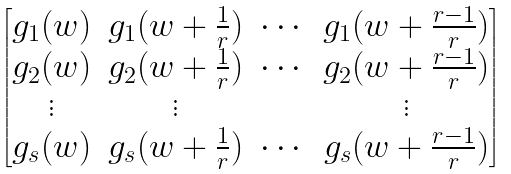Convert formula to latex. <formula><loc_0><loc_0><loc_500><loc_500>\begin{bmatrix} g _ { 1 } ( w ) & g _ { 1 } ( w + \frac { 1 } { r } ) & \cdots & g _ { 1 } ( w + \frac { r - 1 } { r } ) \\ g _ { 2 } ( w ) & g _ { 2 } ( w + \frac { 1 } { r } ) & \cdots & g _ { 2 } ( w + \frac { r - 1 } { r } ) \\ \vdots & \vdots & & \vdots \\ g _ { s } ( w ) & g _ { s } ( w + \frac { 1 } { r } ) & \cdots & g _ { s } ( w + \frac { r - 1 } { r } ) \end{bmatrix}</formula> 